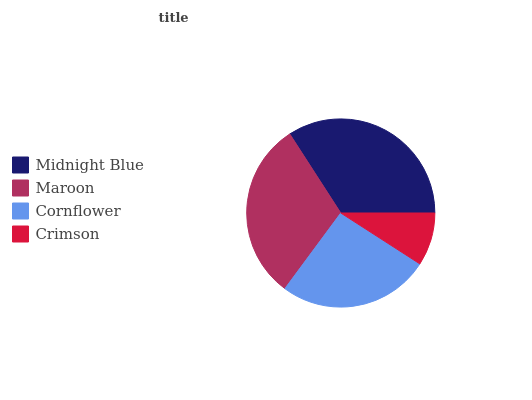Is Crimson the minimum?
Answer yes or no. Yes. Is Midnight Blue the maximum?
Answer yes or no. Yes. Is Maroon the minimum?
Answer yes or no. No. Is Maroon the maximum?
Answer yes or no. No. Is Midnight Blue greater than Maroon?
Answer yes or no. Yes. Is Maroon less than Midnight Blue?
Answer yes or no. Yes. Is Maroon greater than Midnight Blue?
Answer yes or no. No. Is Midnight Blue less than Maroon?
Answer yes or no. No. Is Maroon the high median?
Answer yes or no. Yes. Is Cornflower the low median?
Answer yes or no. Yes. Is Cornflower the high median?
Answer yes or no. No. Is Maroon the low median?
Answer yes or no. No. 